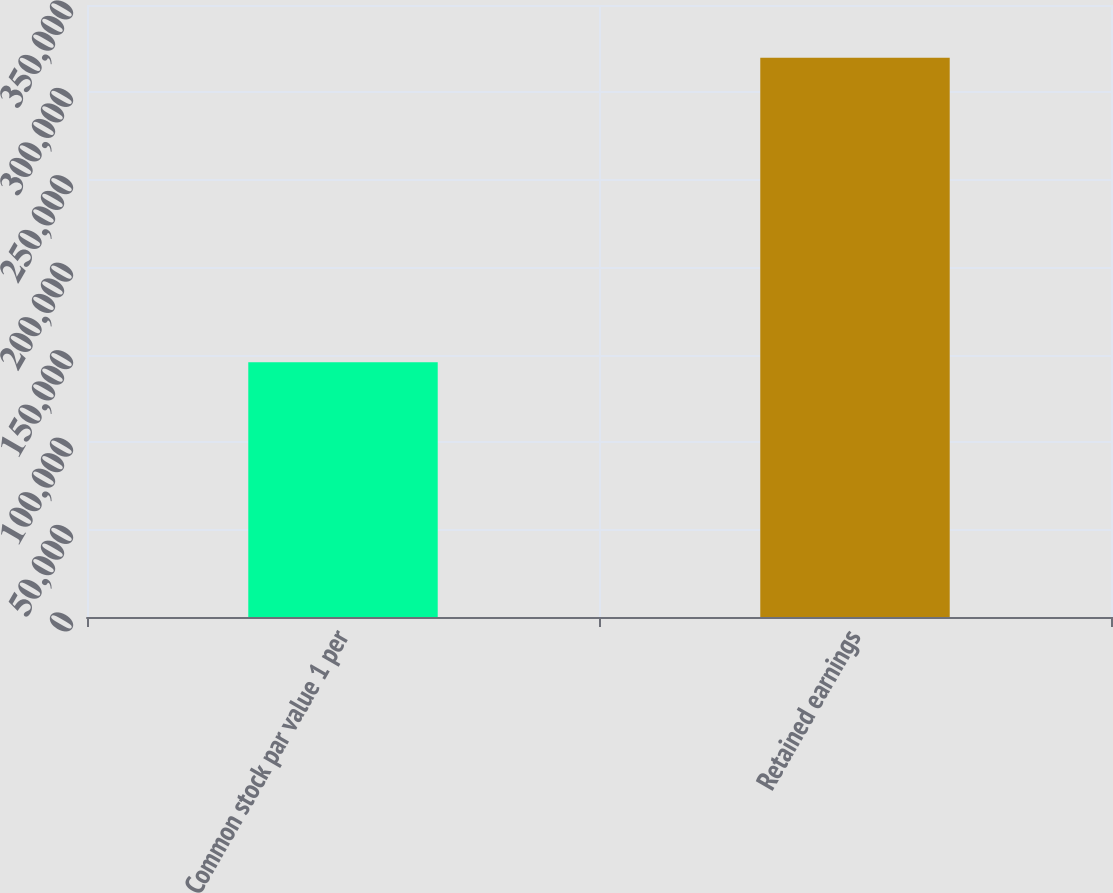<chart> <loc_0><loc_0><loc_500><loc_500><bar_chart><fcel>Common stock par value 1 per<fcel>Retained earnings<nl><fcel>145722<fcel>319803<nl></chart> 